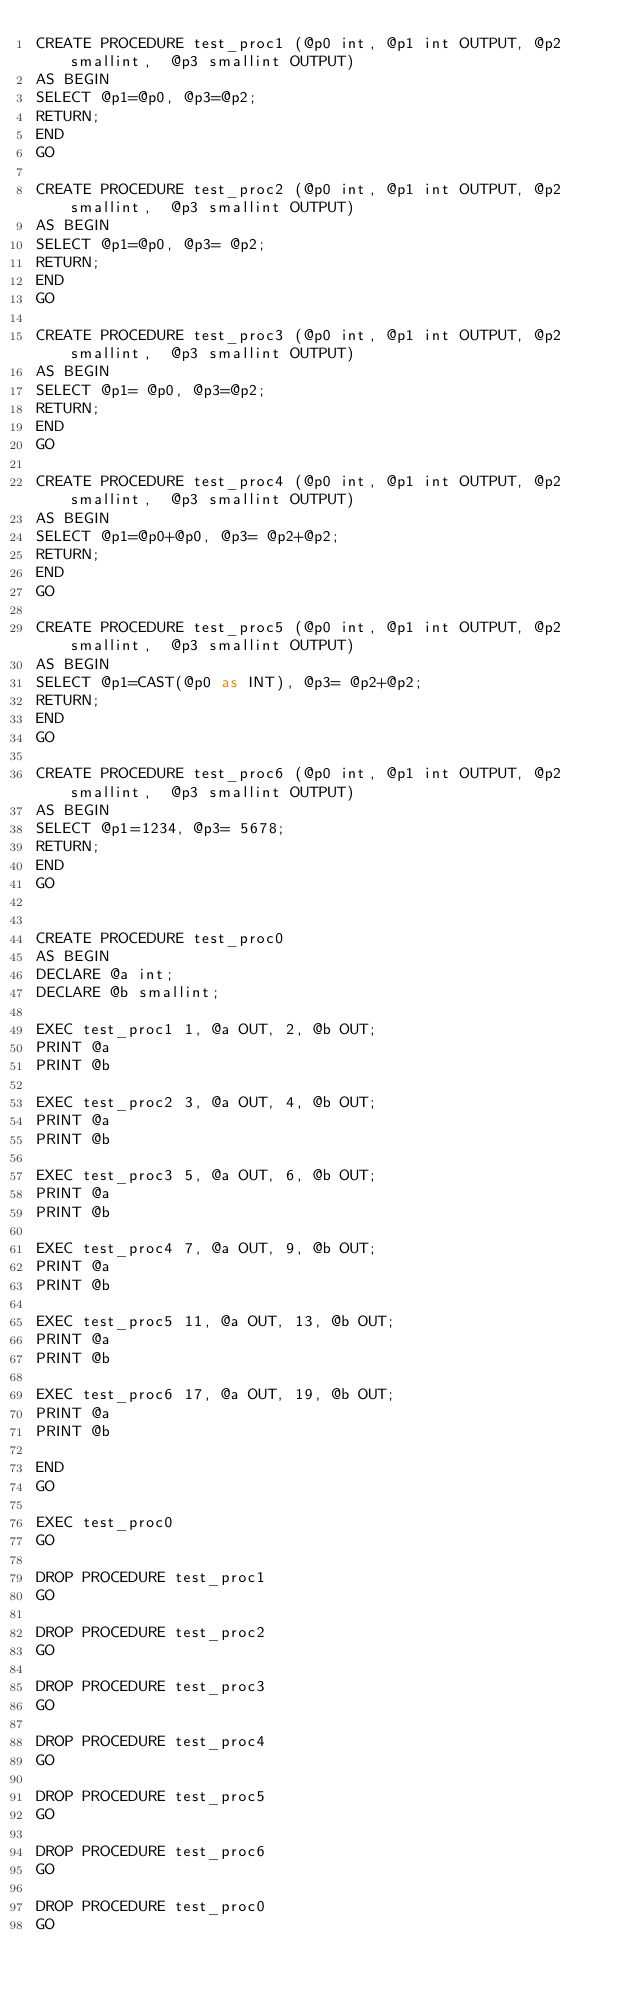<code> <loc_0><loc_0><loc_500><loc_500><_SQL_>CREATE PROCEDURE test_proc1 (@p0 int, @p1 int OUTPUT, @p2 smallint,  @p3 smallint OUTPUT)
AS BEGIN
SELECT @p1=@p0, @p3=@p2;
RETURN;
END
GO

CREATE PROCEDURE test_proc2 (@p0 int, @p1 int OUTPUT, @p2 smallint,  @p3 smallint OUTPUT)
AS BEGIN
SELECT @p1=@p0, @p3= @p2;
RETURN;
END
GO

CREATE PROCEDURE test_proc3 (@p0 int, @p1 int OUTPUT, @p2 smallint,  @p3 smallint OUTPUT)
AS BEGIN
SELECT @p1= @p0, @p3=@p2;
RETURN;
END
GO

CREATE PROCEDURE test_proc4 (@p0 int, @p1 int OUTPUT, @p2 smallint,  @p3 smallint OUTPUT)
AS BEGIN
SELECT @p1=@p0+@p0, @p3= @p2+@p2;
RETURN;
END
GO

CREATE PROCEDURE test_proc5 (@p0 int, @p1 int OUTPUT, @p2 smallint,  @p3 smallint OUTPUT)
AS BEGIN
SELECT @p1=CAST(@p0 as INT), @p3= @p2+@p2;
RETURN;
END
GO

CREATE PROCEDURE test_proc6 (@p0 int, @p1 int OUTPUT, @p2 smallint,  @p3 smallint OUTPUT)
AS BEGIN
SELECT @p1=1234, @p3= 5678;
RETURN;
END
GO


CREATE PROCEDURE test_proc0 
AS BEGIN
DECLARE @a int;
DECLARE @b smallint;

EXEC test_proc1 1, @a OUT, 2, @b OUT;
PRINT @a
PRINT @b

EXEC test_proc2 3, @a OUT, 4, @b OUT;
PRINT @a
PRINT @b

EXEC test_proc3 5, @a OUT, 6, @b OUT;
PRINT @a
PRINT @b

EXEC test_proc4 7, @a OUT, 9, @b OUT;
PRINT @a
PRINT @b

EXEC test_proc5 11, @a OUT, 13, @b OUT;
PRINT @a
PRINT @b

EXEC test_proc6 17, @a OUT, 19, @b OUT;
PRINT @a
PRINT @b

END
GO

EXEC test_proc0
GO

DROP PROCEDURE test_proc1
GO

DROP PROCEDURE test_proc2
GO

DROP PROCEDURE test_proc3
GO

DROP PROCEDURE test_proc4
GO

DROP PROCEDURE test_proc5
GO

DROP PROCEDURE test_proc6
GO

DROP PROCEDURE test_proc0
GO

</code> 